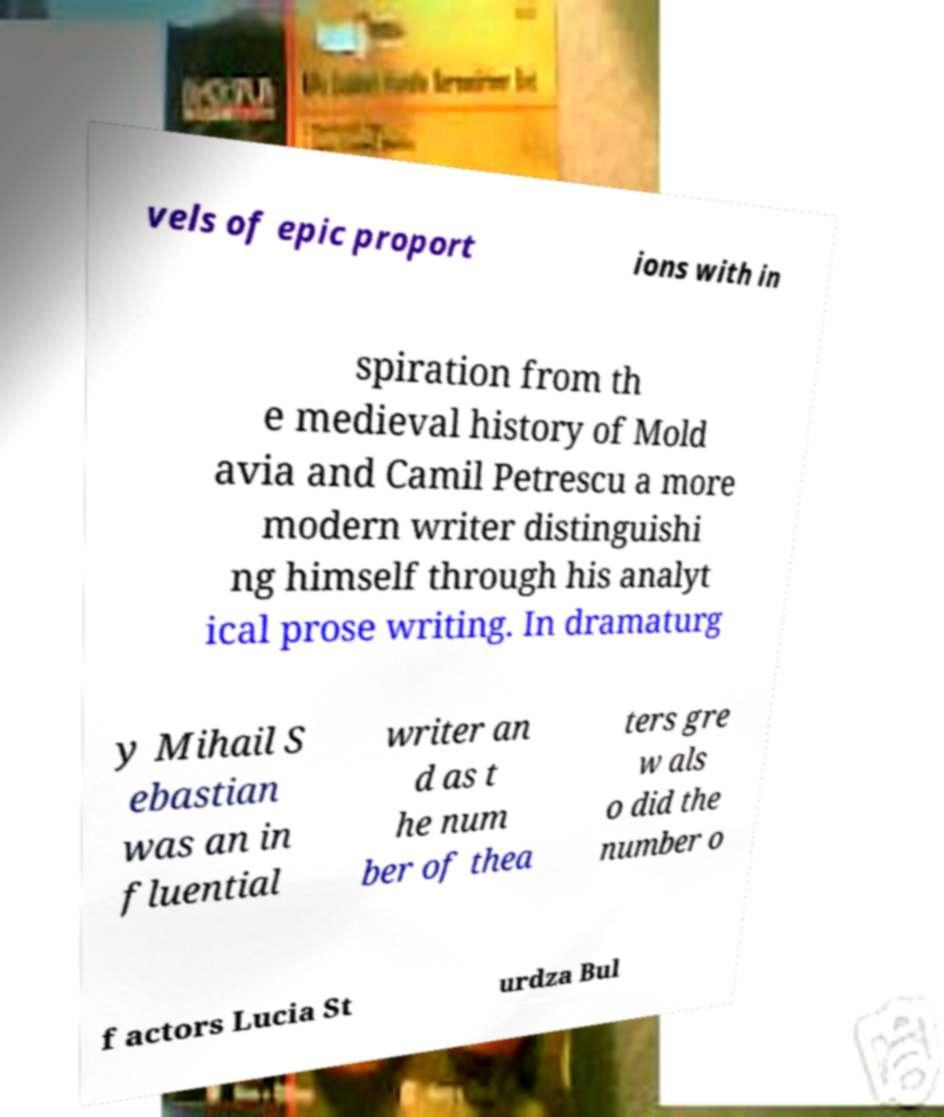What messages or text are displayed in this image? I need them in a readable, typed format. vels of epic proport ions with in spiration from th e medieval history of Mold avia and Camil Petrescu a more modern writer distinguishi ng himself through his analyt ical prose writing. In dramaturg y Mihail S ebastian was an in fluential writer an d as t he num ber of thea ters gre w als o did the number o f actors Lucia St urdza Bul 